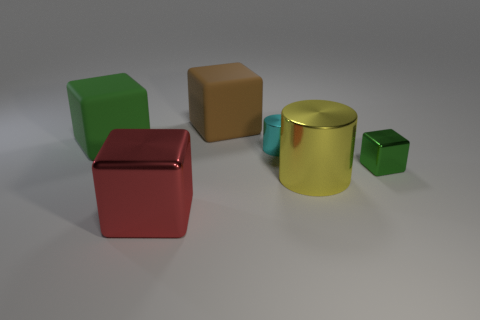Add 2 tiny blue shiny cylinders. How many objects exist? 8 Subtract all gray blocks. Subtract all purple balls. How many blocks are left? 4 Add 1 tiny blocks. How many tiny blocks exist? 2 Subtract 0 gray balls. How many objects are left? 6 Subtract all blocks. How many objects are left? 2 Subtract all matte blocks. Subtract all green matte things. How many objects are left? 3 Add 6 red objects. How many red objects are left? 7 